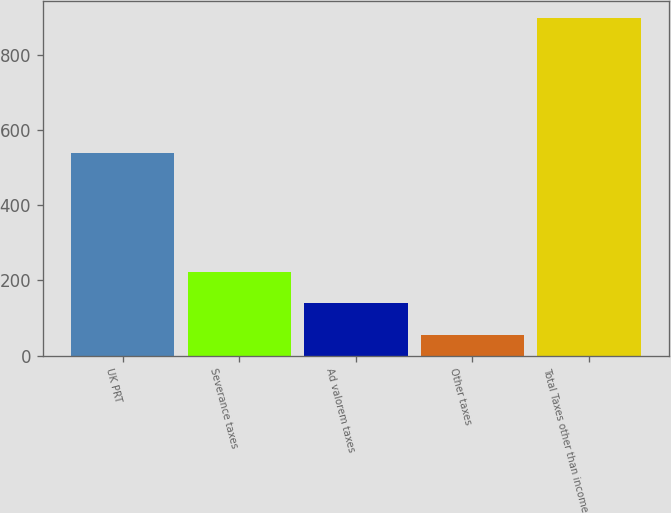Convert chart. <chart><loc_0><loc_0><loc_500><loc_500><bar_chart><fcel>UK PRT<fcel>Severance taxes<fcel>Ad valorem taxes<fcel>Other taxes<fcel>Total Taxes other than income<nl><fcel>538<fcel>223.8<fcel>139.4<fcel>55<fcel>899<nl></chart> 